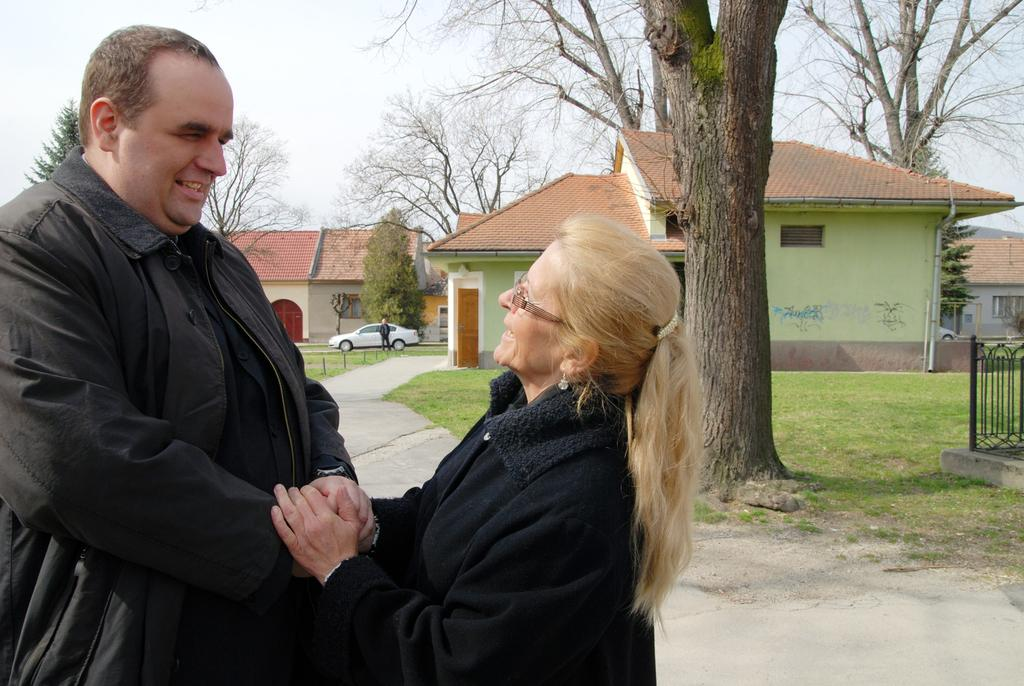How many people are in the image? There are two people standing in the image. What color are the clothes worn by the people in the image? The people are wearing black color dress. What can be seen in the background of the image? Houses, windows, doors, trees, and a white car are visible in the background. What is the color of the sky in the image? The sky appears to be white in color. What type of engine can be seen in the image? There is no engine present in the image. Is there a church visible in the image? No, there is no church visible in the image. 